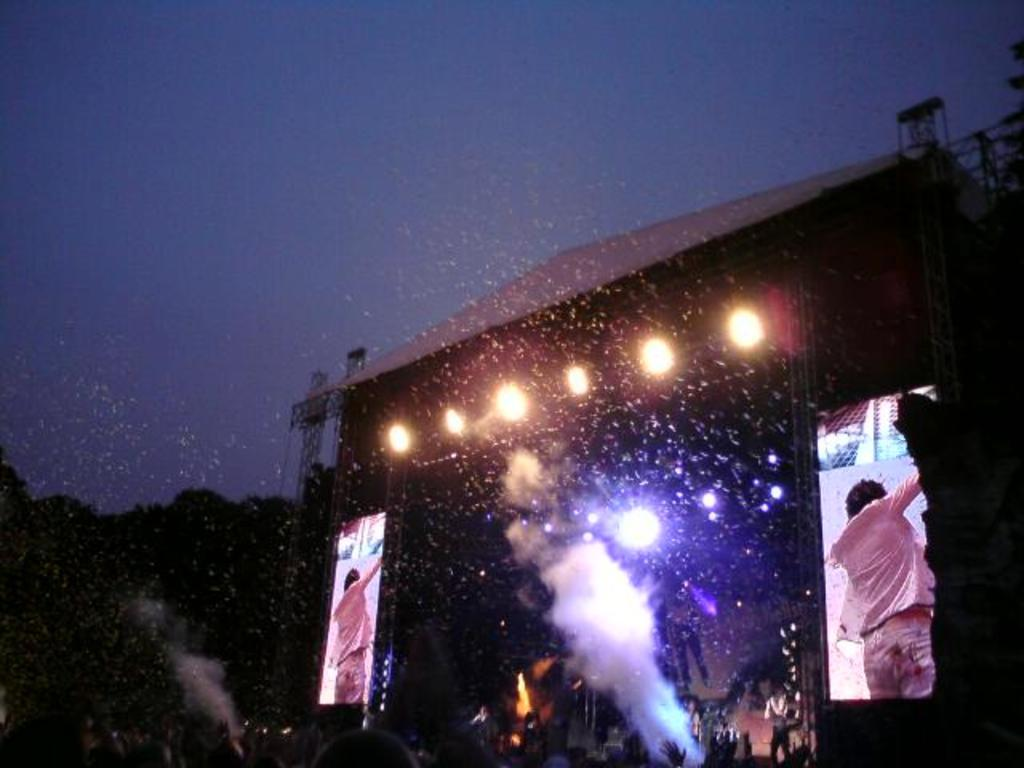What is the main feature of the image? There is a stage in the image. What can be seen on the stage? Stage lights are present in the image, and there are two screens on the stage. What is displayed on the screens? A person is visible on the screens. What is the condition of the sky in the background of the image? The sky is visible in the background of the image. Can you describe any special effects used on the stage? There is smoke in the image. Can you see a snake slithering across the stage in the image? There is no snake present in the image. Is there a ship visible on the stage in the image? There is no ship present in the image. 